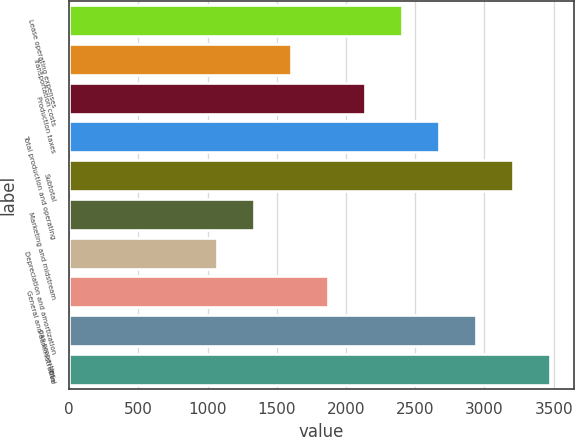Convert chart. <chart><loc_0><loc_0><loc_500><loc_500><bar_chart><fcel>Lease operating expenses<fcel>Transportation costs<fcel>Production taxes<fcel>Total production and operating<fcel>Subtotal<fcel>Marketing and midstream<fcel>Depreciation and amortization<fcel>General and administrative<fcel>gas properties<fcel>Total<nl><fcel>2404.81<fcel>1603.33<fcel>2137.65<fcel>2671.97<fcel>3206.29<fcel>1336.17<fcel>1069.01<fcel>1870.49<fcel>2939.13<fcel>3473.45<nl></chart> 